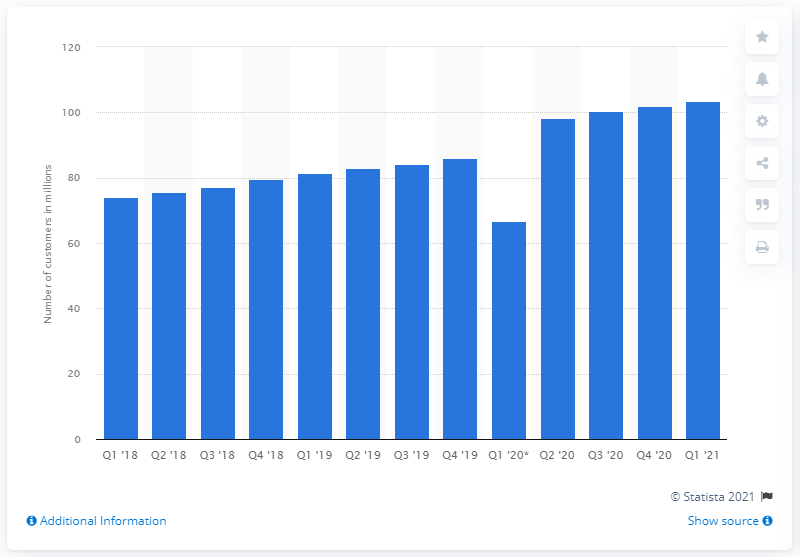Specify some key components in this picture. In the first quarter of 2021, T-Mobile served a total of 103,440 customers. 